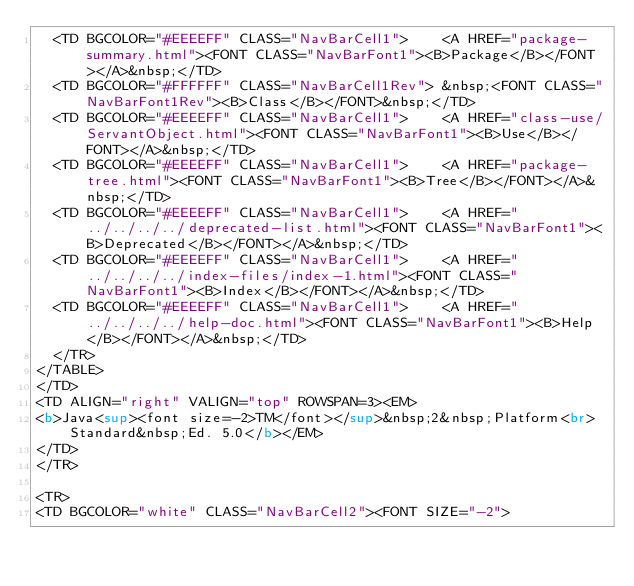Convert code to text. <code><loc_0><loc_0><loc_500><loc_500><_HTML_>  <TD BGCOLOR="#EEEEFF" CLASS="NavBarCell1">    <A HREF="package-summary.html"><FONT CLASS="NavBarFont1"><B>Package</B></FONT></A>&nbsp;</TD>
  <TD BGCOLOR="#FFFFFF" CLASS="NavBarCell1Rev"> &nbsp;<FONT CLASS="NavBarFont1Rev"><B>Class</B></FONT>&nbsp;</TD>
  <TD BGCOLOR="#EEEEFF" CLASS="NavBarCell1">    <A HREF="class-use/ServantObject.html"><FONT CLASS="NavBarFont1"><B>Use</B></FONT></A>&nbsp;</TD>
  <TD BGCOLOR="#EEEEFF" CLASS="NavBarCell1">    <A HREF="package-tree.html"><FONT CLASS="NavBarFont1"><B>Tree</B></FONT></A>&nbsp;</TD>
  <TD BGCOLOR="#EEEEFF" CLASS="NavBarCell1">    <A HREF="../../../../deprecated-list.html"><FONT CLASS="NavBarFont1"><B>Deprecated</B></FONT></A>&nbsp;</TD>
  <TD BGCOLOR="#EEEEFF" CLASS="NavBarCell1">    <A HREF="../../../../index-files/index-1.html"><FONT CLASS="NavBarFont1"><B>Index</B></FONT></A>&nbsp;</TD>
  <TD BGCOLOR="#EEEEFF" CLASS="NavBarCell1">    <A HREF="../../../../help-doc.html"><FONT CLASS="NavBarFont1"><B>Help</B></FONT></A>&nbsp;</TD>
  </TR>
</TABLE>
</TD>
<TD ALIGN="right" VALIGN="top" ROWSPAN=3><EM>
<b>Java<sup><font size=-2>TM</font></sup>&nbsp;2&nbsp;Platform<br>Standard&nbsp;Ed. 5.0</b></EM>
</TD>
</TR>

<TR>
<TD BGCOLOR="white" CLASS="NavBarCell2"><FONT SIZE="-2"></code> 